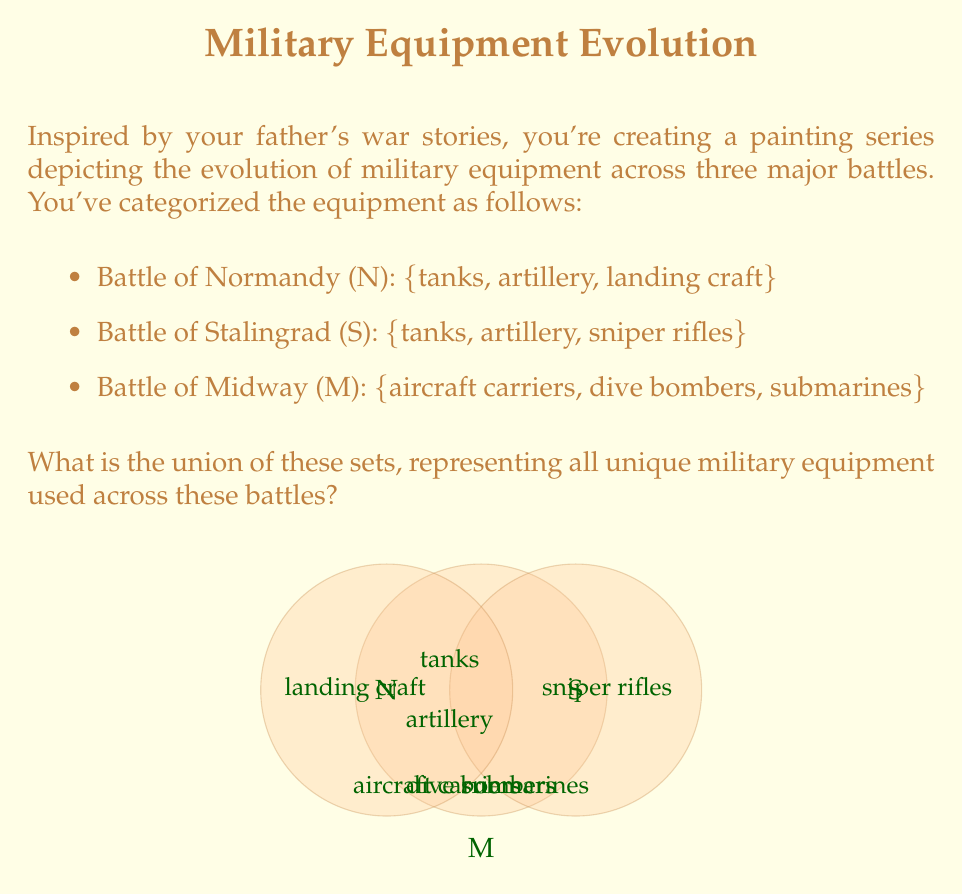Show me your answer to this math problem. To find the union of these sets, we need to combine all unique elements from each set. Let's approach this step-by-step:

1) First, let's define our sets:
   N = $\{$tanks, artillery, landing craft$\}$
   S = $\{$tanks, artillery, sniper rifles$\}$
   M = $\{$aircraft carriers, dive bombers, submarines$\}$

2) The union of these sets is denoted as $N \cup S \cup M$.

3) To find this union, we list all unique elements from all sets:

   - From N: tanks, artillery, landing craft
   - From S: tanks and artillery are already included, so we add sniper rifles
   - From M: aircraft carriers, dive bombers, submarines

4) Notice that tanks and artillery appear in both N and S, but we only include them once in the union.

5) Therefore, the union of these sets contains 7 unique elements:
   $N \cup S \cup M = \{$tanks, artillery, landing craft, sniper rifles, aircraft carriers, dive bombers, submarines$\}$

This union represents all the unique military equipment used across these three battles, providing a comprehensive set of elements for your painting series.
Answer: $\{$tanks, artillery, landing craft, sniper rifles, aircraft carriers, dive bombers, submarines$\}$ 